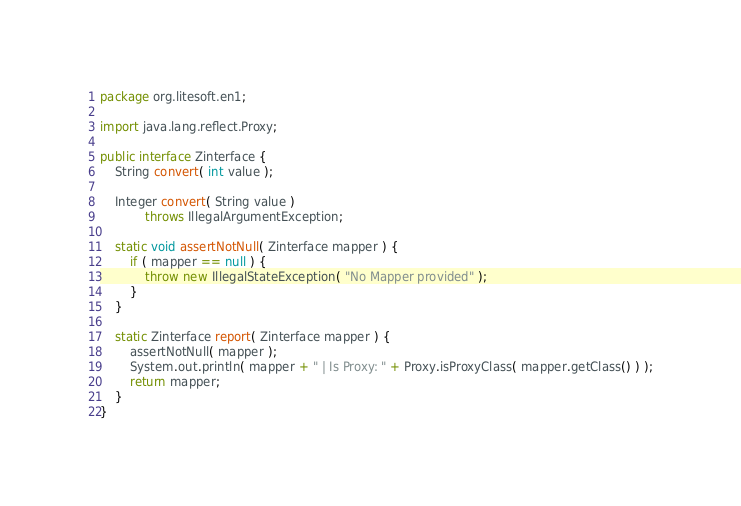Convert code to text. <code><loc_0><loc_0><loc_500><loc_500><_Java_>package org.litesoft.en1;

import java.lang.reflect.Proxy;

public interface Zinterface {
    String convert( int value );

    Integer convert( String value )
            throws IllegalArgumentException;

    static void assertNotNull( Zinterface mapper ) {
        if ( mapper == null ) {
            throw new IllegalStateException( "No Mapper provided" );
        }
    }

    static Zinterface report( Zinterface mapper ) {
        assertNotNull( mapper );
        System.out.println( mapper + " | Is Proxy: " + Proxy.isProxyClass( mapper.getClass() ) );
        return mapper;
    }
}
</code> 